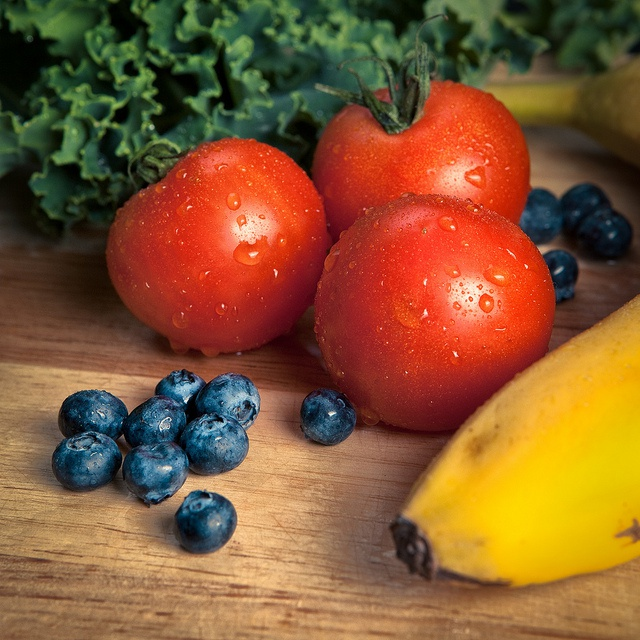Describe the objects in this image and their specific colors. I can see a banana in black, orange, gold, and maroon tones in this image. 